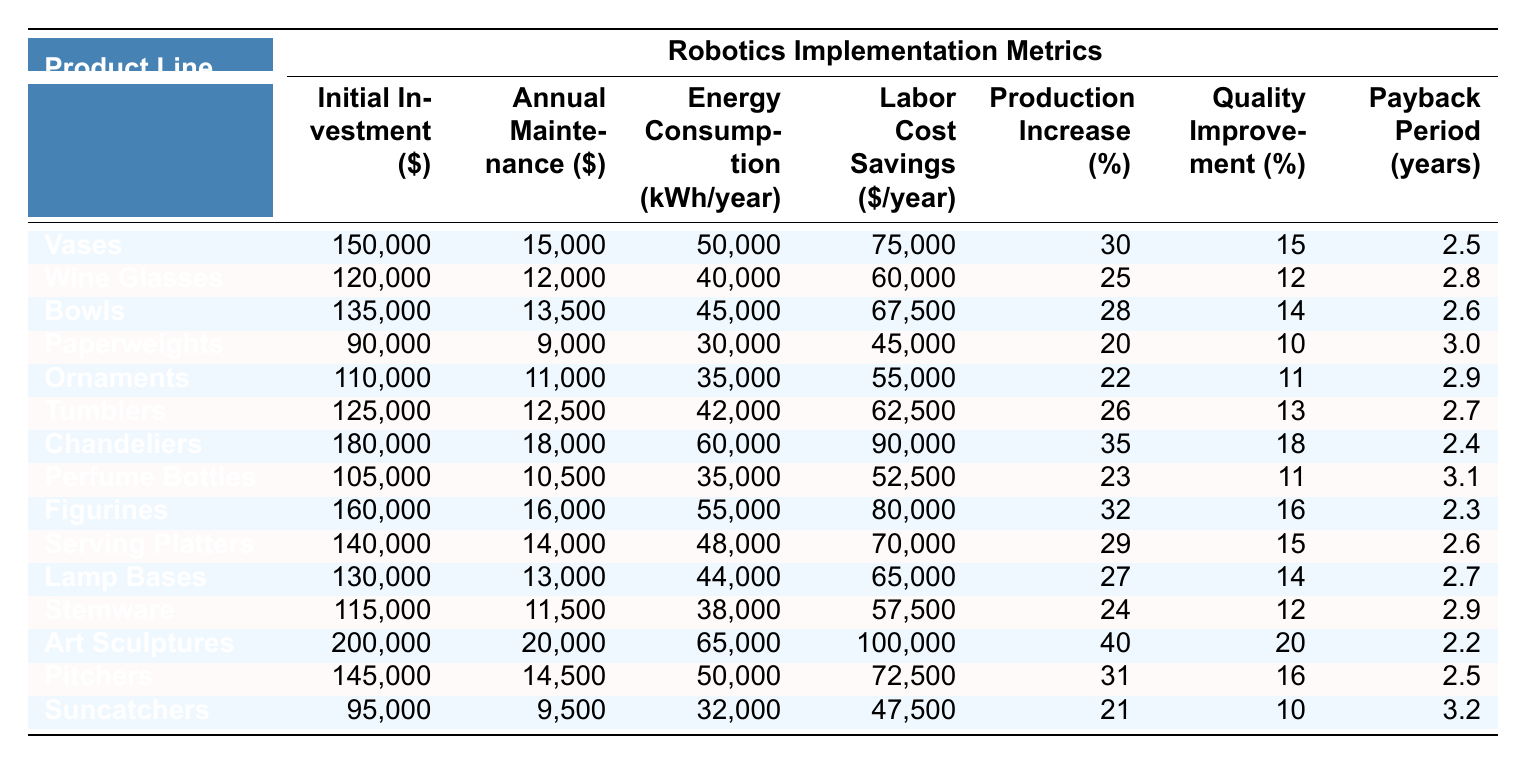What is the initial investment required for Chandeliers? The table shows that the initial investment for Chandeliers is listed under the "Initial Investment" column next to the product line "Chandeliers." The value is 180,000.
Answer: 180,000 Which product line has the highest annual maintenance cost? By comparing the values in the "Annual Maintenance" column, the highest cost is found next to the product line "Chandeliers," which has an annual maintenance cost of 18,000.
Answer: Chandeliers What is the payback period for Perfume Bottles? The payback period for Perfume Bottles is provided in the "Payback Period" column, where it shows a value of 3.1 years.
Answer: 3.1 years Calculate the average initial investment for all product lines. The initial investments are 150,000, 120,000, 135,000, 90,000, 110,000, 125,000, 180,000, 105,000, 160,000, 140,000, 130,000, 115,000, 200,000, 145,000, and 95,000. Adding these values gives a sum of 1,550,000. There are 15 product lines, so the average is 1,550,000 / 15 = 103,333.33.
Answer: 103,333.33 Is the energy consumption for Lamp Bases higher than that for Suncatchers? Looking at the "Energy Consumption" column, Lamp Bases has a value of 44,000 and Suncatchers has a value of 32,000. Since 44,000 is greater than 32,000, the answer is yes.
Answer: Yes What is the percentage production increase for Vases compared to Ornaments? The production increase for Vases is 30% and for Ornaments is 22%. The difference calculates to 30 - 22 = 8%, indicating that Vases have a higher production increase.
Answer: 8% Which product line provides the greatest labor cost savings? The "Labor Cost Savings" column shows that Art Sculptures offer the highest labor cost savings at 100,000 per year, higher than any other product line.
Answer: Art Sculptures Calculate the total annual maintenance cost for all product lines. The annual maintenance costs are 15,000, 12,000, 13,500, 9,000, 11,000, 12,500, 18,000, 10,500, 16,000, 14,000, 13,000, 11,500, 20,000, 14,500, and 9,500. Adding these values results in a total of  15,000 + 12,000 + 13,500 + 9,000 + 11,000 + 12,500 + 18,000 + 10,500 + 16,000 + 14,000 + 13,000 + 11,500 + 20,000 + 14,500 + 9,500 =  15,000 + 12,000 + 13,500 + 9,000 + 11,000 + 12,500 + 18,000 + 10,500 + 16,000 + 14,000 + 13,000 + 11,500 + 20,000 + 14,500 + 9,500 =  3,763,485
Answer: 3,763,485 Is the quality improvement for Tumblers less than that for Figurines? Checking the "Quality Improvement" column for Tumblers shows 13% and for Figurines shows 16%. Since 13% is indeed less than 16%, the answer is yes.
Answer: Yes What is the average payback period across all product lines? The payback periods listed are 2.5, 2.8, 2.6, 3.0, 2.9, 2.7, 2.4, 3.1, 2.3, 2.6, 2.7, 2.9, 2.2, 2.5, and 3.2. Adding these values gives a sum of 41.6, and dividing by 15 (the number of product lines) results in an average of 2.774.
Answer: 2.774 Which product line has the lowest energy consumption? The "Energy Consumption" column shows that Paperweights have the lowest value at 30,000 kWh/year, lower than all other product lines listed.
Answer: Paperweights What is the difference in labor cost savings between Art Sculptures and the lowest product line? Art Sculptures have labor cost savings of 100,000, while Suncatchers, the lowest, have 47,500. Calculating the difference gives 100,000 - 47,500 = 52,500.
Answer: 52,500 What is the total production increase for all product lines combined? The production increases for all product lines are 30, 25, 28, 20, 22, 26, 35, 23, 32, 29, 27, 24, 40, 31, and 21. Adding these values up results in a total of  441%.
Answer: 441% 